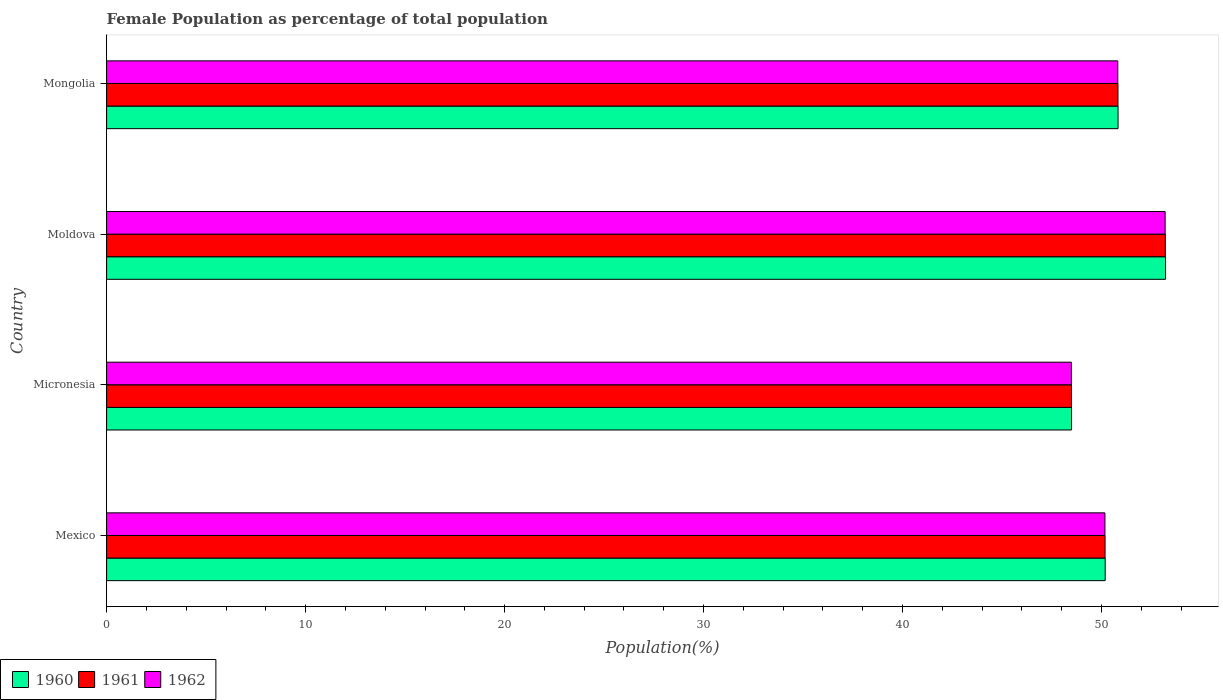How many different coloured bars are there?
Your answer should be very brief. 3. Are the number of bars per tick equal to the number of legend labels?
Your response must be concise. Yes. How many bars are there on the 4th tick from the bottom?
Keep it short and to the point. 3. In how many cases, is the number of bars for a given country not equal to the number of legend labels?
Provide a succinct answer. 0. What is the female population in in 1961 in Mexico?
Your answer should be compact. 50.18. Across all countries, what is the maximum female population in in 1962?
Provide a short and direct response. 53.19. Across all countries, what is the minimum female population in in 1962?
Make the answer very short. 48.48. In which country was the female population in in 1961 maximum?
Your response must be concise. Moldova. In which country was the female population in in 1960 minimum?
Keep it short and to the point. Micronesia. What is the total female population in in 1960 in the graph?
Give a very brief answer. 202.72. What is the difference between the female population in in 1961 in Micronesia and that in Moldova?
Make the answer very short. -4.72. What is the difference between the female population in in 1962 in Moldova and the female population in in 1960 in Mongolia?
Keep it short and to the point. 2.37. What is the average female population in in 1962 per country?
Your answer should be very brief. 50.67. What is the difference between the female population in in 1962 and female population in in 1961 in Mongolia?
Provide a succinct answer. -0.01. In how many countries, is the female population in in 1961 greater than 20 %?
Provide a short and direct response. 4. What is the ratio of the female population in in 1962 in Mexico to that in Mongolia?
Offer a very short reply. 0.99. Is the female population in in 1961 in Mexico less than that in Mongolia?
Keep it short and to the point. Yes. What is the difference between the highest and the second highest female population in in 1960?
Your answer should be compact. 2.39. What is the difference between the highest and the lowest female population in in 1962?
Ensure brevity in your answer.  4.71. Does the graph contain any zero values?
Make the answer very short. No. Does the graph contain grids?
Offer a very short reply. No. How many legend labels are there?
Make the answer very short. 3. What is the title of the graph?
Ensure brevity in your answer.  Female Population as percentage of total population. What is the label or title of the X-axis?
Your response must be concise. Population(%). What is the Population(%) of 1960 in Mexico?
Give a very brief answer. 50.18. What is the Population(%) of 1961 in Mexico?
Your answer should be compact. 50.18. What is the Population(%) in 1962 in Mexico?
Offer a very short reply. 50.17. What is the Population(%) in 1960 in Micronesia?
Provide a succinct answer. 48.49. What is the Population(%) of 1961 in Micronesia?
Provide a short and direct response. 48.49. What is the Population(%) in 1962 in Micronesia?
Ensure brevity in your answer.  48.48. What is the Population(%) in 1960 in Moldova?
Keep it short and to the point. 53.21. What is the Population(%) of 1961 in Moldova?
Offer a very short reply. 53.2. What is the Population(%) of 1962 in Moldova?
Provide a succinct answer. 53.19. What is the Population(%) in 1960 in Mongolia?
Ensure brevity in your answer.  50.83. What is the Population(%) in 1961 in Mongolia?
Keep it short and to the point. 50.82. What is the Population(%) in 1962 in Mongolia?
Provide a succinct answer. 50.82. Across all countries, what is the maximum Population(%) of 1960?
Offer a very short reply. 53.21. Across all countries, what is the maximum Population(%) in 1961?
Offer a very short reply. 53.2. Across all countries, what is the maximum Population(%) in 1962?
Your answer should be very brief. 53.19. Across all countries, what is the minimum Population(%) in 1960?
Provide a short and direct response. 48.49. Across all countries, what is the minimum Population(%) in 1961?
Give a very brief answer. 48.49. Across all countries, what is the minimum Population(%) of 1962?
Provide a succinct answer. 48.48. What is the total Population(%) of 1960 in the graph?
Your response must be concise. 202.72. What is the total Population(%) of 1961 in the graph?
Make the answer very short. 202.69. What is the total Population(%) of 1962 in the graph?
Your response must be concise. 202.66. What is the difference between the Population(%) of 1960 in Mexico and that in Micronesia?
Keep it short and to the point. 1.69. What is the difference between the Population(%) in 1961 in Mexico and that in Micronesia?
Provide a succinct answer. 1.69. What is the difference between the Population(%) of 1962 in Mexico and that in Micronesia?
Ensure brevity in your answer.  1.69. What is the difference between the Population(%) in 1960 in Mexico and that in Moldova?
Offer a terse response. -3.03. What is the difference between the Population(%) in 1961 in Mexico and that in Moldova?
Offer a terse response. -3.03. What is the difference between the Population(%) of 1962 in Mexico and that in Moldova?
Your response must be concise. -3.02. What is the difference between the Population(%) in 1960 in Mexico and that in Mongolia?
Provide a succinct answer. -0.65. What is the difference between the Population(%) in 1961 in Mexico and that in Mongolia?
Provide a succinct answer. -0.65. What is the difference between the Population(%) of 1962 in Mexico and that in Mongolia?
Make the answer very short. -0.65. What is the difference between the Population(%) in 1960 in Micronesia and that in Moldova?
Provide a short and direct response. -4.72. What is the difference between the Population(%) of 1961 in Micronesia and that in Moldova?
Your answer should be compact. -4.72. What is the difference between the Population(%) in 1962 in Micronesia and that in Moldova?
Offer a terse response. -4.71. What is the difference between the Population(%) in 1960 in Micronesia and that in Mongolia?
Provide a succinct answer. -2.34. What is the difference between the Population(%) of 1961 in Micronesia and that in Mongolia?
Your answer should be compact. -2.34. What is the difference between the Population(%) of 1962 in Micronesia and that in Mongolia?
Provide a succinct answer. -2.33. What is the difference between the Population(%) of 1960 in Moldova and that in Mongolia?
Offer a very short reply. 2.39. What is the difference between the Population(%) of 1961 in Moldova and that in Mongolia?
Make the answer very short. 2.38. What is the difference between the Population(%) of 1962 in Moldova and that in Mongolia?
Offer a very short reply. 2.38. What is the difference between the Population(%) in 1960 in Mexico and the Population(%) in 1961 in Micronesia?
Give a very brief answer. 1.69. What is the difference between the Population(%) of 1960 in Mexico and the Population(%) of 1962 in Micronesia?
Offer a very short reply. 1.7. What is the difference between the Population(%) of 1961 in Mexico and the Population(%) of 1962 in Micronesia?
Provide a short and direct response. 1.69. What is the difference between the Population(%) of 1960 in Mexico and the Population(%) of 1961 in Moldova?
Make the answer very short. -3.02. What is the difference between the Population(%) in 1960 in Mexico and the Population(%) in 1962 in Moldova?
Provide a succinct answer. -3.01. What is the difference between the Population(%) of 1961 in Mexico and the Population(%) of 1962 in Moldova?
Give a very brief answer. -3.02. What is the difference between the Population(%) of 1960 in Mexico and the Population(%) of 1961 in Mongolia?
Provide a succinct answer. -0.64. What is the difference between the Population(%) of 1960 in Mexico and the Population(%) of 1962 in Mongolia?
Ensure brevity in your answer.  -0.63. What is the difference between the Population(%) of 1961 in Mexico and the Population(%) of 1962 in Mongolia?
Make the answer very short. -0.64. What is the difference between the Population(%) in 1960 in Micronesia and the Population(%) in 1961 in Moldova?
Provide a succinct answer. -4.71. What is the difference between the Population(%) of 1960 in Micronesia and the Population(%) of 1962 in Moldova?
Your response must be concise. -4.7. What is the difference between the Population(%) of 1961 in Micronesia and the Population(%) of 1962 in Moldova?
Offer a very short reply. -4.71. What is the difference between the Population(%) in 1960 in Micronesia and the Population(%) in 1961 in Mongolia?
Your answer should be compact. -2.33. What is the difference between the Population(%) in 1960 in Micronesia and the Population(%) in 1962 in Mongolia?
Your response must be concise. -2.32. What is the difference between the Population(%) of 1961 in Micronesia and the Population(%) of 1962 in Mongolia?
Provide a short and direct response. -2.33. What is the difference between the Population(%) in 1960 in Moldova and the Population(%) in 1961 in Mongolia?
Provide a succinct answer. 2.39. What is the difference between the Population(%) in 1960 in Moldova and the Population(%) in 1962 in Mongolia?
Ensure brevity in your answer.  2.4. What is the difference between the Population(%) in 1961 in Moldova and the Population(%) in 1962 in Mongolia?
Offer a very short reply. 2.39. What is the average Population(%) in 1960 per country?
Keep it short and to the point. 50.68. What is the average Population(%) in 1961 per country?
Give a very brief answer. 50.67. What is the average Population(%) of 1962 per country?
Offer a terse response. 50.67. What is the difference between the Population(%) in 1960 and Population(%) in 1961 in Mexico?
Your response must be concise. 0.01. What is the difference between the Population(%) of 1960 and Population(%) of 1962 in Mexico?
Your answer should be compact. 0.01. What is the difference between the Population(%) of 1961 and Population(%) of 1962 in Mexico?
Offer a terse response. 0.01. What is the difference between the Population(%) in 1960 and Population(%) in 1961 in Micronesia?
Give a very brief answer. 0. What is the difference between the Population(%) of 1960 and Population(%) of 1962 in Micronesia?
Your answer should be very brief. 0.01. What is the difference between the Population(%) in 1961 and Population(%) in 1962 in Micronesia?
Offer a terse response. 0.01. What is the difference between the Population(%) in 1960 and Population(%) in 1961 in Moldova?
Offer a very short reply. 0.01. What is the difference between the Population(%) of 1960 and Population(%) of 1962 in Moldova?
Provide a short and direct response. 0.02. What is the difference between the Population(%) in 1961 and Population(%) in 1962 in Moldova?
Your response must be concise. 0.01. What is the difference between the Population(%) in 1960 and Population(%) in 1961 in Mongolia?
Your response must be concise. 0. What is the difference between the Population(%) in 1960 and Population(%) in 1962 in Mongolia?
Make the answer very short. 0.01. What is the difference between the Population(%) of 1961 and Population(%) of 1962 in Mongolia?
Provide a short and direct response. 0.01. What is the ratio of the Population(%) in 1960 in Mexico to that in Micronesia?
Your answer should be very brief. 1.03. What is the ratio of the Population(%) in 1961 in Mexico to that in Micronesia?
Your answer should be compact. 1.03. What is the ratio of the Population(%) of 1962 in Mexico to that in Micronesia?
Provide a short and direct response. 1.03. What is the ratio of the Population(%) of 1960 in Mexico to that in Moldova?
Keep it short and to the point. 0.94. What is the ratio of the Population(%) in 1961 in Mexico to that in Moldova?
Your answer should be compact. 0.94. What is the ratio of the Population(%) of 1962 in Mexico to that in Moldova?
Your answer should be very brief. 0.94. What is the ratio of the Population(%) of 1960 in Mexico to that in Mongolia?
Your answer should be compact. 0.99. What is the ratio of the Population(%) in 1961 in Mexico to that in Mongolia?
Your response must be concise. 0.99. What is the ratio of the Population(%) in 1962 in Mexico to that in Mongolia?
Offer a very short reply. 0.99. What is the ratio of the Population(%) of 1960 in Micronesia to that in Moldova?
Make the answer very short. 0.91. What is the ratio of the Population(%) of 1961 in Micronesia to that in Moldova?
Ensure brevity in your answer.  0.91. What is the ratio of the Population(%) of 1962 in Micronesia to that in Moldova?
Make the answer very short. 0.91. What is the ratio of the Population(%) in 1960 in Micronesia to that in Mongolia?
Provide a succinct answer. 0.95. What is the ratio of the Population(%) of 1961 in Micronesia to that in Mongolia?
Give a very brief answer. 0.95. What is the ratio of the Population(%) of 1962 in Micronesia to that in Mongolia?
Give a very brief answer. 0.95. What is the ratio of the Population(%) in 1960 in Moldova to that in Mongolia?
Offer a very short reply. 1.05. What is the ratio of the Population(%) of 1961 in Moldova to that in Mongolia?
Your response must be concise. 1.05. What is the ratio of the Population(%) in 1962 in Moldova to that in Mongolia?
Ensure brevity in your answer.  1.05. What is the difference between the highest and the second highest Population(%) in 1960?
Your response must be concise. 2.39. What is the difference between the highest and the second highest Population(%) in 1961?
Make the answer very short. 2.38. What is the difference between the highest and the second highest Population(%) in 1962?
Your answer should be compact. 2.38. What is the difference between the highest and the lowest Population(%) of 1960?
Ensure brevity in your answer.  4.72. What is the difference between the highest and the lowest Population(%) of 1961?
Your response must be concise. 4.72. What is the difference between the highest and the lowest Population(%) of 1962?
Your answer should be compact. 4.71. 